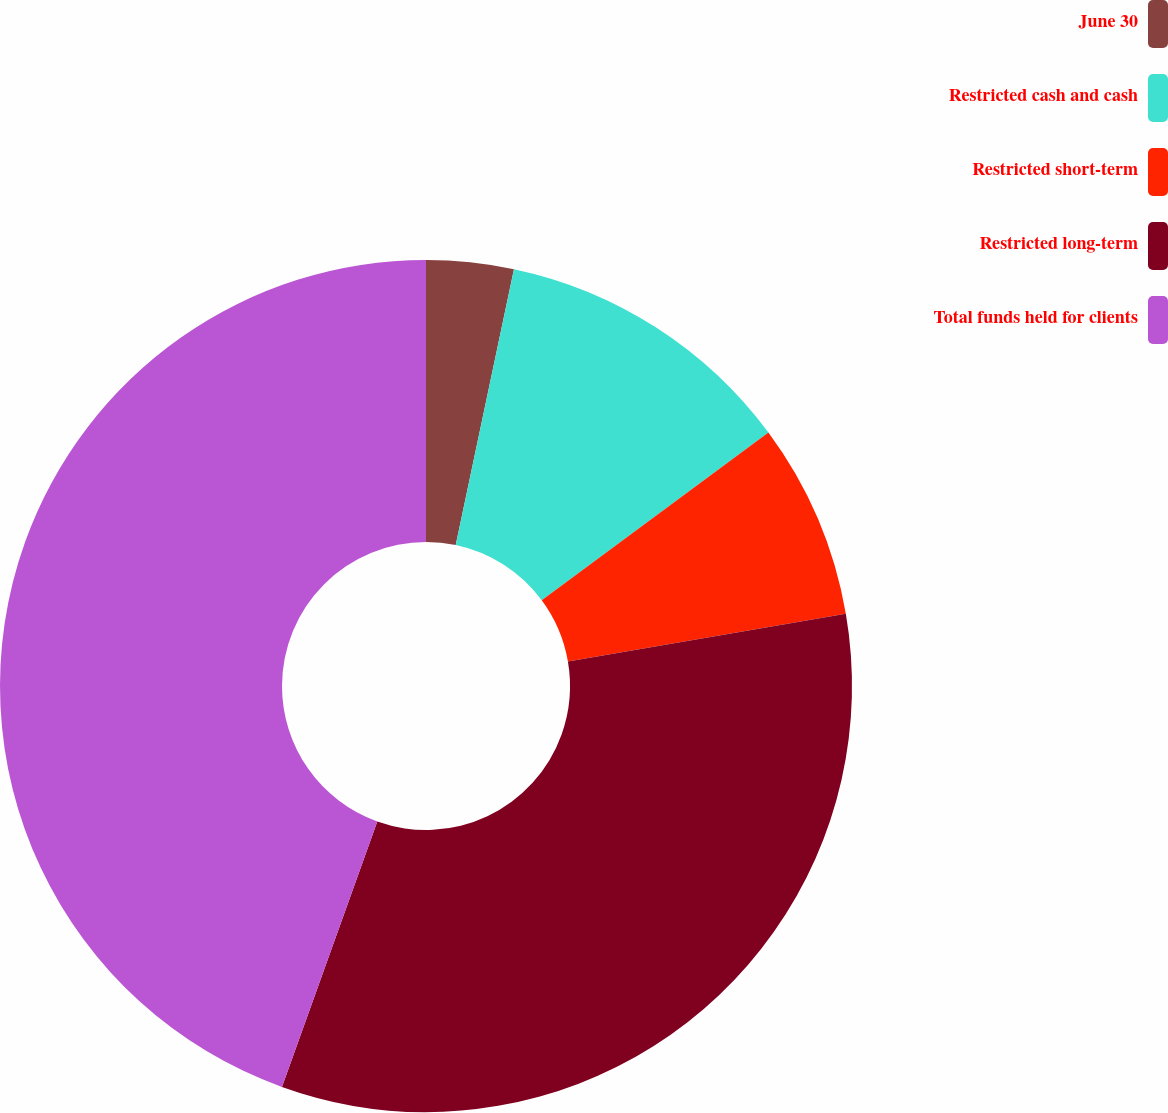Convert chart to OTSL. <chart><loc_0><loc_0><loc_500><loc_500><pie_chart><fcel>June 30<fcel>Restricted cash and cash<fcel>Restricted short-term<fcel>Restricted long-term<fcel>Total funds held for clients<nl><fcel>3.31%<fcel>11.55%<fcel>7.43%<fcel>33.2%<fcel>44.51%<nl></chart> 